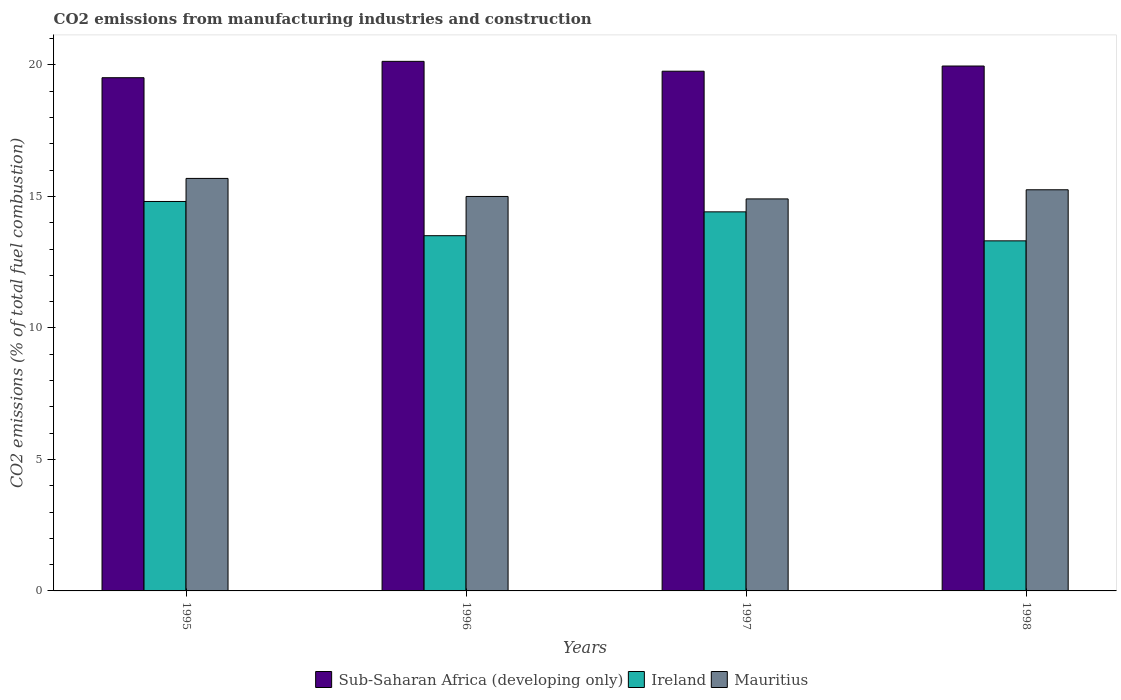How many different coloured bars are there?
Provide a short and direct response. 3. How many groups of bars are there?
Your answer should be compact. 4. Are the number of bars per tick equal to the number of legend labels?
Keep it short and to the point. Yes. How many bars are there on the 1st tick from the right?
Give a very brief answer. 3. What is the label of the 4th group of bars from the left?
Your response must be concise. 1998. What is the amount of CO2 emitted in Ireland in 1997?
Ensure brevity in your answer.  14.41. Across all years, what is the maximum amount of CO2 emitted in Sub-Saharan Africa (developing only)?
Offer a terse response. 20.14. Across all years, what is the minimum amount of CO2 emitted in Sub-Saharan Africa (developing only)?
Offer a very short reply. 19.52. In which year was the amount of CO2 emitted in Mauritius maximum?
Make the answer very short. 1995. In which year was the amount of CO2 emitted in Mauritius minimum?
Give a very brief answer. 1997. What is the total amount of CO2 emitted in Ireland in the graph?
Offer a very short reply. 56.04. What is the difference between the amount of CO2 emitted in Ireland in 1996 and that in 1998?
Provide a short and direct response. 0.2. What is the difference between the amount of CO2 emitted in Ireland in 1998 and the amount of CO2 emitted in Sub-Saharan Africa (developing only) in 1995?
Provide a short and direct response. -6.2. What is the average amount of CO2 emitted in Mauritius per year?
Ensure brevity in your answer.  15.21. In the year 1995, what is the difference between the amount of CO2 emitted in Sub-Saharan Africa (developing only) and amount of CO2 emitted in Mauritius?
Give a very brief answer. 3.83. In how many years, is the amount of CO2 emitted in Mauritius greater than 2 %?
Keep it short and to the point. 4. What is the ratio of the amount of CO2 emitted in Ireland in 1995 to that in 1996?
Offer a very short reply. 1.1. Is the amount of CO2 emitted in Mauritius in 1995 less than that in 1998?
Your answer should be very brief. No. What is the difference between the highest and the second highest amount of CO2 emitted in Sub-Saharan Africa (developing only)?
Make the answer very short. 0.18. What is the difference between the highest and the lowest amount of CO2 emitted in Ireland?
Give a very brief answer. 1.5. What does the 1st bar from the left in 1997 represents?
Your answer should be very brief. Sub-Saharan Africa (developing only). What does the 3rd bar from the right in 1997 represents?
Make the answer very short. Sub-Saharan Africa (developing only). Is it the case that in every year, the sum of the amount of CO2 emitted in Sub-Saharan Africa (developing only) and amount of CO2 emitted in Ireland is greater than the amount of CO2 emitted in Mauritius?
Your answer should be compact. Yes. Are all the bars in the graph horizontal?
Your answer should be very brief. No. What is the difference between two consecutive major ticks on the Y-axis?
Offer a very short reply. 5. Are the values on the major ticks of Y-axis written in scientific E-notation?
Give a very brief answer. No. Does the graph contain any zero values?
Ensure brevity in your answer.  No. Does the graph contain grids?
Provide a short and direct response. No. What is the title of the graph?
Provide a succinct answer. CO2 emissions from manufacturing industries and construction. What is the label or title of the X-axis?
Offer a terse response. Years. What is the label or title of the Y-axis?
Your answer should be compact. CO2 emissions (% of total fuel combustion). What is the CO2 emissions (% of total fuel combustion) of Sub-Saharan Africa (developing only) in 1995?
Offer a terse response. 19.52. What is the CO2 emissions (% of total fuel combustion) of Ireland in 1995?
Your response must be concise. 14.81. What is the CO2 emissions (% of total fuel combustion) of Mauritius in 1995?
Make the answer very short. 15.69. What is the CO2 emissions (% of total fuel combustion) in Sub-Saharan Africa (developing only) in 1996?
Provide a short and direct response. 20.14. What is the CO2 emissions (% of total fuel combustion) of Ireland in 1996?
Offer a very short reply. 13.51. What is the CO2 emissions (% of total fuel combustion) of Mauritius in 1996?
Provide a succinct answer. 15. What is the CO2 emissions (% of total fuel combustion) in Sub-Saharan Africa (developing only) in 1997?
Offer a terse response. 19.76. What is the CO2 emissions (% of total fuel combustion) of Ireland in 1997?
Make the answer very short. 14.41. What is the CO2 emissions (% of total fuel combustion) in Mauritius in 1997?
Make the answer very short. 14.91. What is the CO2 emissions (% of total fuel combustion) in Sub-Saharan Africa (developing only) in 1998?
Offer a terse response. 19.96. What is the CO2 emissions (% of total fuel combustion) in Ireland in 1998?
Ensure brevity in your answer.  13.31. What is the CO2 emissions (% of total fuel combustion) of Mauritius in 1998?
Make the answer very short. 15.25. Across all years, what is the maximum CO2 emissions (% of total fuel combustion) of Sub-Saharan Africa (developing only)?
Keep it short and to the point. 20.14. Across all years, what is the maximum CO2 emissions (% of total fuel combustion) of Ireland?
Offer a very short reply. 14.81. Across all years, what is the maximum CO2 emissions (% of total fuel combustion) in Mauritius?
Make the answer very short. 15.69. Across all years, what is the minimum CO2 emissions (% of total fuel combustion) in Sub-Saharan Africa (developing only)?
Ensure brevity in your answer.  19.52. Across all years, what is the minimum CO2 emissions (% of total fuel combustion) in Ireland?
Provide a succinct answer. 13.31. Across all years, what is the minimum CO2 emissions (% of total fuel combustion) of Mauritius?
Offer a terse response. 14.91. What is the total CO2 emissions (% of total fuel combustion) in Sub-Saharan Africa (developing only) in the graph?
Offer a terse response. 79.38. What is the total CO2 emissions (% of total fuel combustion) of Ireland in the graph?
Provide a succinct answer. 56.04. What is the total CO2 emissions (% of total fuel combustion) of Mauritius in the graph?
Ensure brevity in your answer.  60.85. What is the difference between the CO2 emissions (% of total fuel combustion) of Sub-Saharan Africa (developing only) in 1995 and that in 1996?
Offer a very short reply. -0.62. What is the difference between the CO2 emissions (% of total fuel combustion) in Ireland in 1995 and that in 1996?
Make the answer very short. 1.3. What is the difference between the CO2 emissions (% of total fuel combustion) in Mauritius in 1995 and that in 1996?
Offer a very short reply. 0.69. What is the difference between the CO2 emissions (% of total fuel combustion) in Sub-Saharan Africa (developing only) in 1995 and that in 1997?
Make the answer very short. -0.25. What is the difference between the CO2 emissions (% of total fuel combustion) of Ireland in 1995 and that in 1997?
Provide a short and direct response. 0.39. What is the difference between the CO2 emissions (% of total fuel combustion) in Mauritius in 1995 and that in 1997?
Keep it short and to the point. 0.78. What is the difference between the CO2 emissions (% of total fuel combustion) in Sub-Saharan Africa (developing only) in 1995 and that in 1998?
Provide a succinct answer. -0.44. What is the difference between the CO2 emissions (% of total fuel combustion) in Ireland in 1995 and that in 1998?
Your answer should be compact. 1.5. What is the difference between the CO2 emissions (% of total fuel combustion) in Mauritius in 1995 and that in 1998?
Provide a short and direct response. 0.43. What is the difference between the CO2 emissions (% of total fuel combustion) of Sub-Saharan Africa (developing only) in 1996 and that in 1997?
Your answer should be very brief. 0.38. What is the difference between the CO2 emissions (% of total fuel combustion) in Ireland in 1996 and that in 1997?
Make the answer very short. -0.91. What is the difference between the CO2 emissions (% of total fuel combustion) of Mauritius in 1996 and that in 1997?
Your response must be concise. 0.09. What is the difference between the CO2 emissions (% of total fuel combustion) in Sub-Saharan Africa (developing only) in 1996 and that in 1998?
Keep it short and to the point. 0.18. What is the difference between the CO2 emissions (% of total fuel combustion) of Ireland in 1996 and that in 1998?
Offer a terse response. 0.2. What is the difference between the CO2 emissions (% of total fuel combustion) in Mauritius in 1996 and that in 1998?
Give a very brief answer. -0.25. What is the difference between the CO2 emissions (% of total fuel combustion) of Sub-Saharan Africa (developing only) in 1997 and that in 1998?
Keep it short and to the point. -0.2. What is the difference between the CO2 emissions (% of total fuel combustion) of Ireland in 1997 and that in 1998?
Give a very brief answer. 1.1. What is the difference between the CO2 emissions (% of total fuel combustion) of Mauritius in 1997 and that in 1998?
Ensure brevity in your answer.  -0.35. What is the difference between the CO2 emissions (% of total fuel combustion) in Sub-Saharan Africa (developing only) in 1995 and the CO2 emissions (% of total fuel combustion) in Ireland in 1996?
Provide a short and direct response. 6.01. What is the difference between the CO2 emissions (% of total fuel combustion) in Sub-Saharan Africa (developing only) in 1995 and the CO2 emissions (% of total fuel combustion) in Mauritius in 1996?
Offer a very short reply. 4.52. What is the difference between the CO2 emissions (% of total fuel combustion) in Ireland in 1995 and the CO2 emissions (% of total fuel combustion) in Mauritius in 1996?
Offer a terse response. -0.19. What is the difference between the CO2 emissions (% of total fuel combustion) in Sub-Saharan Africa (developing only) in 1995 and the CO2 emissions (% of total fuel combustion) in Ireland in 1997?
Offer a very short reply. 5.1. What is the difference between the CO2 emissions (% of total fuel combustion) of Sub-Saharan Africa (developing only) in 1995 and the CO2 emissions (% of total fuel combustion) of Mauritius in 1997?
Ensure brevity in your answer.  4.61. What is the difference between the CO2 emissions (% of total fuel combustion) of Ireland in 1995 and the CO2 emissions (% of total fuel combustion) of Mauritius in 1997?
Provide a short and direct response. -0.1. What is the difference between the CO2 emissions (% of total fuel combustion) of Sub-Saharan Africa (developing only) in 1995 and the CO2 emissions (% of total fuel combustion) of Ireland in 1998?
Keep it short and to the point. 6.2. What is the difference between the CO2 emissions (% of total fuel combustion) of Sub-Saharan Africa (developing only) in 1995 and the CO2 emissions (% of total fuel combustion) of Mauritius in 1998?
Give a very brief answer. 4.26. What is the difference between the CO2 emissions (% of total fuel combustion) of Ireland in 1995 and the CO2 emissions (% of total fuel combustion) of Mauritius in 1998?
Give a very brief answer. -0.45. What is the difference between the CO2 emissions (% of total fuel combustion) of Sub-Saharan Africa (developing only) in 1996 and the CO2 emissions (% of total fuel combustion) of Ireland in 1997?
Provide a succinct answer. 5.72. What is the difference between the CO2 emissions (% of total fuel combustion) of Sub-Saharan Africa (developing only) in 1996 and the CO2 emissions (% of total fuel combustion) of Mauritius in 1997?
Give a very brief answer. 5.23. What is the difference between the CO2 emissions (% of total fuel combustion) in Ireland in 1996 and the CO2 emissions (% of total fuel combustion) in Mauritius in 1997?
Provide a short and direct response. -1.4. What is the difference between the CO2 emissions (% of total fuel combustion) of Sub-Saharan Africa (developing only) in 1996 and the CO2 emissions (% of total fuel combustion) of Ireland in 1998?
Offer a terse response. 6.83. What is the difference between the CO2 emissions (% of total fuel combustion) in Sub-Saharan Africa (developing only) in 1996 and the CO2 emissions (% of total fuel combustion) in Mauritius in 1998?
Give a very brief answer. 4.88. What is the difference between the CO2 emissions (% of total fuel combustion) in Ireland in 1996 and the CO2 emissions (% of total fuel combustion) in Mauritius in 1998?
Keep it short and to the point. -1.75. What is the difference between the CO2 emissions (% of total fuel combustion) of Sub-Saharan Africa (developing only) in 1997 and the CO2 emissions (% of total fuel combustion) of Ireland in 1998?
Your response must be concise. 6.45. What is the difference between the CO2 emissions (% of total fuel combustion) in Sub-Saharan Africa (developing only) in 1997 and the CO2 emissions (% of total fuel combustion) in Mauritius in 1998?
Ensure brevity in your answer.  4.51. What is the difference between the CO2 emissions (% of total fuel combustion) of Ireland in 1997 and the CO2 emissions (% of total fuel combustion) of Mauritius in 1998?
Provide a succinct answer. -0.84. What is the average CO2 emissions (% of total fuel combustion) of Sub-Saharan Africa (developing only) per year?
Your answer should be very brief. 19.84. What is the average CO2 emissions (% of total fuel combustion) of Ireland per year?
Your answer should be very brief. 14.01. What is the average CO2 emissions (% of total fuel combustion) of Mauritius per year?
Make the answer very short. 15.21. In the year 1995, what is the difference between the CO2 emissions (% of total fuel combustion) of Sub-Saharan Africa (developing only) and CO2 emissions (% of total fuel combustion) of Ireland?
Offer a very short reply. 4.71. In the year 1995, what is the difference between the CO2 emissions (% of total fuel combustion) of Sub-Saharan Africa (developing only) and CO2 emissions (% of total fuel combustion) of Mauritius?
Offer a very short reply. 3.83. In the year 1995, what is the difference between the CO2 emissions (% of total fuel combustion) of Ireland and CO2 emissions (% of total fuel combustion) of Mauritius?
Offer a very short reply. -0.88. In the year 1996, what is the difference between the CO2 emissions (% of total fuel combustion) of Sub-Saharan Africa (developing only) and CO2 emissions (% of total fuel combustion) of Ireland?
Ensure brevity in your answer.  6.63. In the year 1996, what is the difference between the CO2 emissions (% of total fuel combustion) of Sub-Saharan Africa (developing only) and CO2 emissions (% of total fuel combustion) of Mauritius?
Offer a very short reply. 5.14. In the year 1996, what is the difference between the CO2 emissions (% of total fuel combustion) of Ireland and CO2 emissions (% of total fuel combustion) of Mauritius?
Ensure brevity in your answer.  -1.49. In the year 1997, what is the difference between the CO2 emissions (% of total fuel combustion) in Sub-Saharan Africa (developing only) and CO2 emissions (% of total fuel combustion) in Ireland?
Ensure brevity in your answer.  5.35. In the year 1997, what is the difference between the CO2 emissions (% of total fuel combustion) in Sub-Saharan Africa (developing only) and CO2 emissions (% of total fuel combustion) in Mauritius?
Your answer should be very brief. 4.86. In the year 1997, what is the difference between the CO2 emissions (% of total fuel combustion) in Ireland and CO2 emissions (% of total fuel combustion) in Mauritius?
Offer a terse response. -0.49. In the year 1998, what is the difference between the CO2 emissions (% of total fuel combustion) of Sub-Saharan Africa (developing only) and CO2 emissions (% of total fuel combustion) of Ireland?
Ensure brevity in your answer.  6.65. In the year 1998, what is the difference between the CO2 emissions (% of total fuel combustion) in Sub-Saharan Africa (developing only) and CO2 emissions (% of total fuel combustion) in Mauritius?
Make the answer very short. 4.71. In the year 1998, what is the difference between the CO2 emissions (% of total fuel combustion) of Ireland and CO2 emissions (% of total fuel combustion) of Mauritius?
Offer a very short reply. -1.94. What is the ratio of the CO2 emissions (% of total fuel combustion) of Sub-Saharan Africa (developing only) in 1995 to that in 1996?
Your answer should be compact. 0.97. What is the ratio of the CO2 emissions (% of total fuel combustion) in Ireland in 1995 to that in 1996?
Offer a very short reply. 1.1. What is the ratio of the CO2 emissions (% of total fuel combustion) in Mauritius in 1995 to that in 1996?
Ensure brevity in your answer.  1.05. What is the ratio of the CO2 emissions (% of total fuel combustion) in Sub-Saharan Africa (developing only) in 1995 to that in 1997?
Give a very brief answer. 0.99. What is the ratio of the CO2 emissions (% of total fuel combustion) in Ireland in 1995 to that in 1997?
Ensure brevity in your answer.  1.03. What is the ratio of the CO2 emissions (% of total fuel combustion) of Mauritius in 1995 to that in 1997?
Offer a terse response. 1.05. What is the ratio of the CO2 emissions (% of total fuel combustion) in Sub-Saharan Africa (developing only) in 1995 to that in 1998?
Make the answer very short. 0.98. What is the ratio of the CO2 emissions (% of total fuel combustion) in Ireland in 1995 to that in 1998?
Provide a succinct answer. 1.11. What is the ratio of the CO2 emissions (% of total fuel combustion) of Mauritius in 1995 to that in 1998?
Offer a very short reply. 1.03. What is the ratio of the CO2 emissions (% of total fuel combustion) in Ireland in 1996 to that in 1997?
Provide a short and direct response. 0.94. What is the ratio of the CO2 emissions (% of total fuel combustion) in Sub-Saharan Africa (developing only) in 1996 to that in 1998?
Your answer should be compact. 1.01. What is the ratio of the CO2 emissions (% of total fuel combustion) in Ireland in 1996 to that in 1998?
Your response must be concise. 1.01. What is the ratio of the CO2 emissions (% of total fuel combustion) of Mauritius in 1996 to that in 1998?
Offer a terse response. 0.98. What is the ratio of the CO2 emissions (% of total fuel combustion) of Ireland in 1997 to that in 1998?
Keep it short and to the point. 1.08. What is the ratio of the CO2 emissions (% of total fuel combustion) in Mauritius in 1997 to that in 1998?
Give a very brief answer. 0.98. What is the difference between the highest and the second highest CO2 emissions (% of total fuel combustion) in Sub-Saharan Africa (developing only)?
Provide a short and direct response. 0.18. What is the difference between the highest and the second highest CO2 emissions (% of total fuel combustion) of Ireland?
Provide a short and direct response. 0.39. What is the difference between the highest and the second highest CO2 emissions (% of total fuel combustion) of Mauritius?
Offer a terse response. 0.43. What is the difference between the highest and the lowest CO2 emissions (% of total fuel combustion) in Sub-Saharan Africa (developing only)?
Provide a short and direct response. 0.62. What is the difference between the highest and the lowest CO2 emissions (% of total fuel combustion) of Ireland?
Your response must be concise. 1.5. What is the difference between the highest and the lowest CO2 emissions (% of total fuel combustion) of Mauritius?
Give a very brief answer. 0.78. 